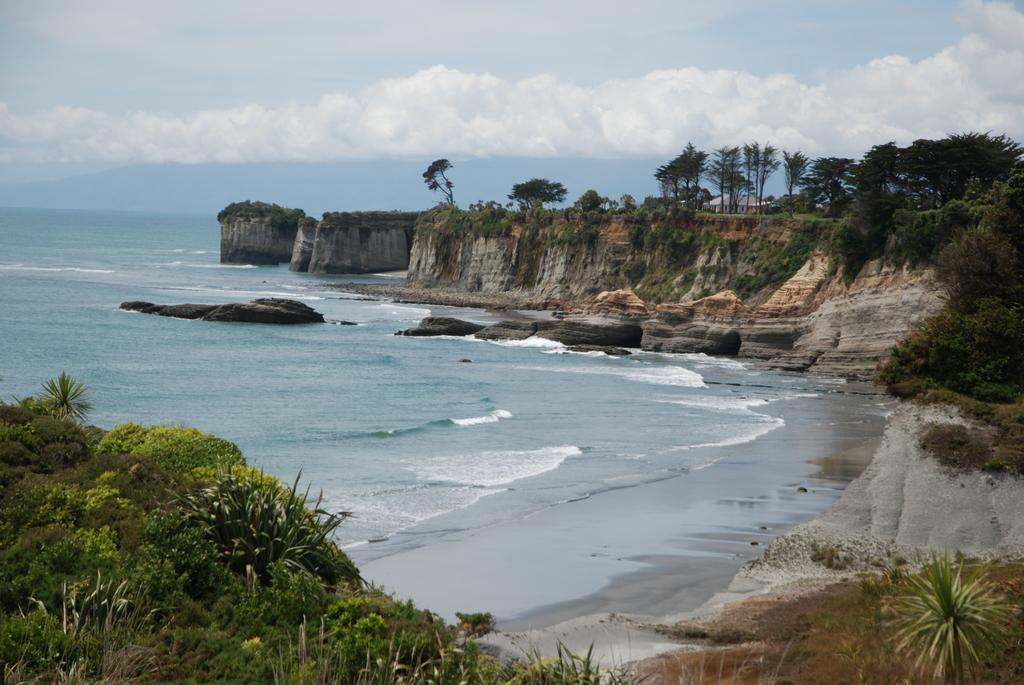What is the primary element in the image? There is water in the image. What other natural elements can be seen in the image? There are rocks and trees in the image. What type of structure is visible in the background of the image? There is a house in the background of the image. What can be seen in the sky in the image? There are clouds visible in the background of the image. How many times does the person in the image sneeze? There is no person present in the image, so it is not possible to determine how many times they sneeze. What type of yard is visible in the image? There is no yard visible in the image; it features water, rocks, trees, a house, and clouds. 